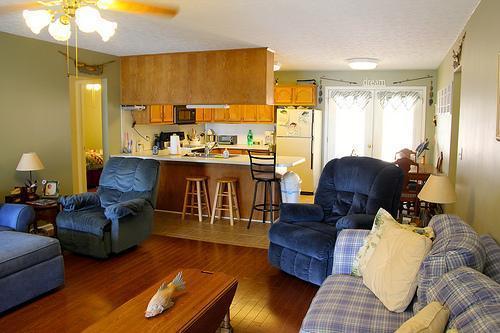How many recliners are in the room?
Give a very brief answer. 2. 